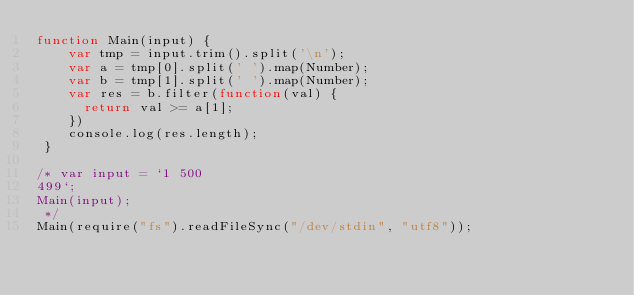Convert code to text. <code><loc_0><loc_0><loc_500><loc_500><_JavaScript_>function Main(input) {
    var tmp = input.trim().split('\n');
    var a = tmp[0].split(' ').map(Number);
    var b = tmp[1].split(' ').map(Number);
    var res = b.filter(function(val) {
      return val >= a[1];
    })
    console.log(res.length);
 }
 
/* var input = `1 500
499`;
Main(input);
 */  
Main(require("fs").readFileSync("/dev/stdin", "utf8"));</code> 